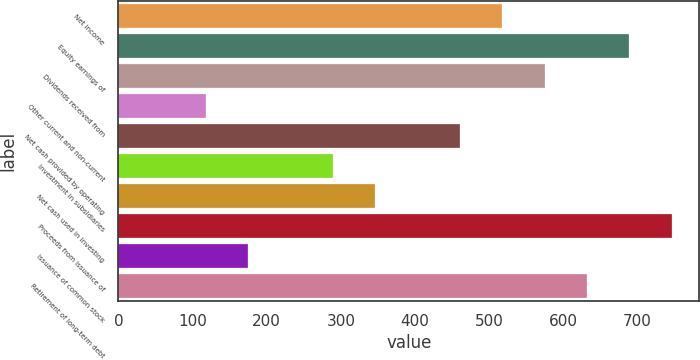Convert chart to OTSL. <chart><loc_0><loc_0><loc_500><loc_500><bar_chart><fcel>Net income<fcel>Equity earnings of<fcel>Dividends received from<fcel>Other current and non-current<fcel>Net cash provided by operating<fcel>Investment in subsidiaries<fcel>Net cash used in investing<fcel>Proceeds from issuance of<fcel>Issuance of common stock<fcel>Retirement of long-term debt<nl><fcel>517.9<fcel>689.2<fcel>575<fcel>118.2<fcel>460.8<fcel>289.5<fcel>346.6<fcel>746.3<fcel>175.3<fcel>632.1<nl></chart> 